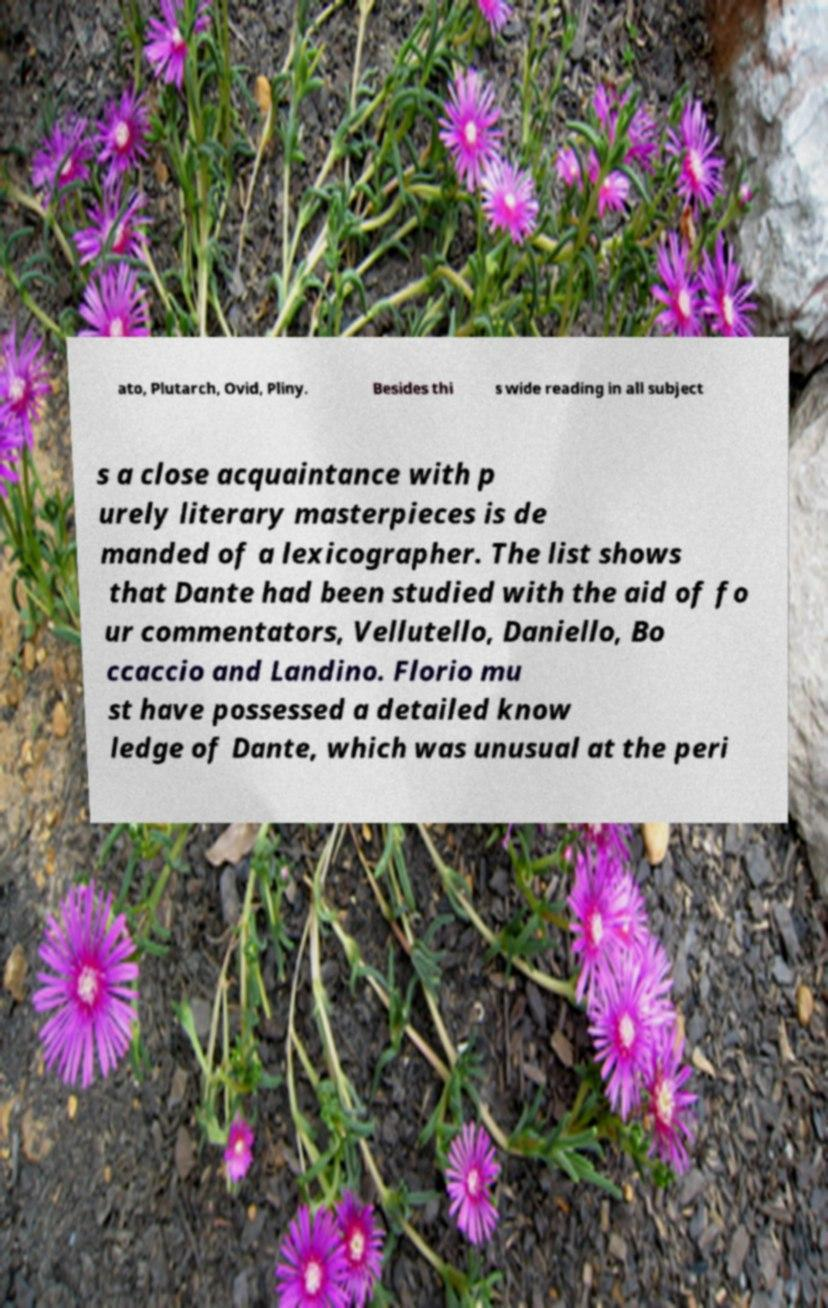Please identify and transcribe the text found in this image. ato, Plutarch, Ovid, Pliny. Besides thi s wide reading in all subject s a close acquaintance with p urely literary masterpieces is de manded of a lexicographer. The list shows that Dante had been studied with the aid of fo ur commentators, Vellutello, Daniello, Bo ccaccio and Landino. Florio mu st have possessed a detailed know ledge of Dante, which was unusual at the peri 